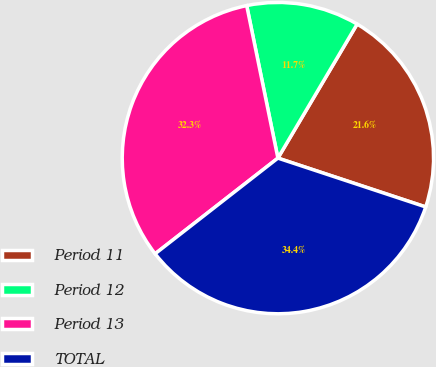<chart> <loc_0><loc_0><loc_500><loc_500><pie_chart><fcel>Period 11<fcel>Period 12<fcel>Period 13<fcel>TOTAL<nl><fcel>21.58%<fcel>11.71%<fcel>32.32%<fcel>34.38%<nl></chart> 